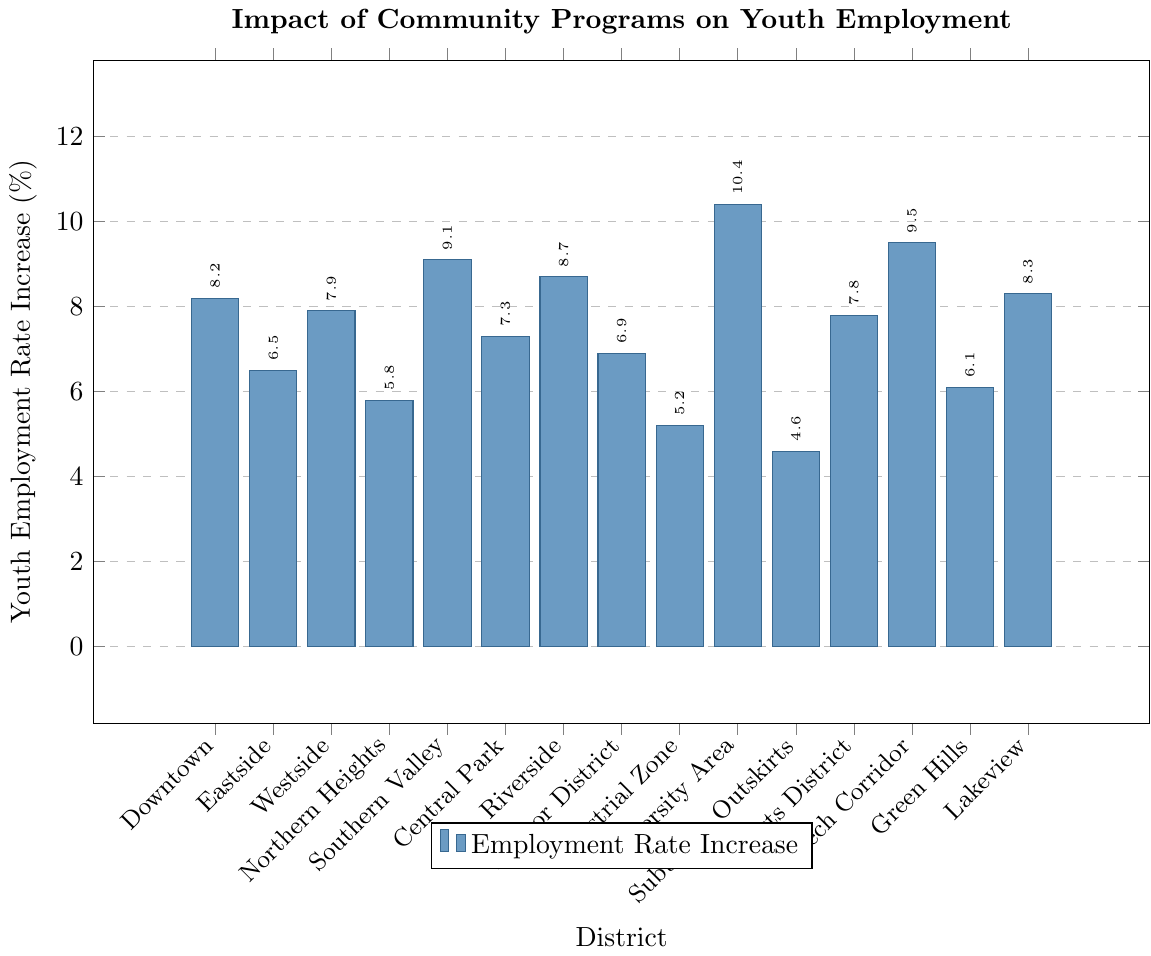Which district has the highest increase in youth employment rates? Look at the bar chart and identify the tallest bar. The tallest bar represents University Area with an increase of 10.4%.
Answer: University Area Which district has the lowest increase in youth employment rates? Look at the bar chart and identify the shortest bar. The shortest bar represents Suburban Outskirts with an increase of 4.6%.
Answer: Suburban Outskirts What is the average youth employment rate increase across all districts? Sum up all the percentage increases and divide by the number of districts: (8.2 + 6.5 + 7.9 + 5.8 + 9.1 + 7.3 + 8.7 + 6.9 + 5.2 + 10.4 + 4.6 + 7.8 + 9.5 + 6.1 + 8.3) / 15 = 7.4
Answer: 7.4 How much higher is the increase in youth employment rates in University Area compared to Central Park? Subtract the increase in Central Park from the increase in University Area: 10.4% - 7.3% = 3.1%
Answer: 3.1% Are there any districts with the same youth employment rate increase? The bar chart's bars have unique lengths for each district, indicating that no two districts have the same rate increase.
Answer: No Which district's youth employment rate increase is closest to the average rate increase? The average increase is 7.4%. The closest value to 7.4% is Central Park with an increase of 7.3%.
Answer: Central Park What is the total increase in youth employment rates for districts with rates above 8%? Identify districts with rates above 8% and sum their increases: Downtown (8.2%), Southern Valley (9.1%), Riverside (8.7%), University Area (10.4%), Tech Corridor (9.5%), Lakeview (8.3%): 8.2 + 9.1 + 8.7 + 10.4 + 9.5 + 8.3 = 54.2%
Answer: 54.2% How much more did Tech Corridor increase compared to Northern Heights? Subtract the increase in Northern Heights from the increase in Tech Corridor: 9.5% - 5.8% = 3.7%
Answer: 3.7% In terms of youth employment rate increase, which districts are immediately above and below Green Hills? Look at Green Hills with an increase of 6.1%. The district immediately above is Eastside with 6.5% and below is Northern Heights with 5.8%.
Answer: Eastside and Northern Heights 